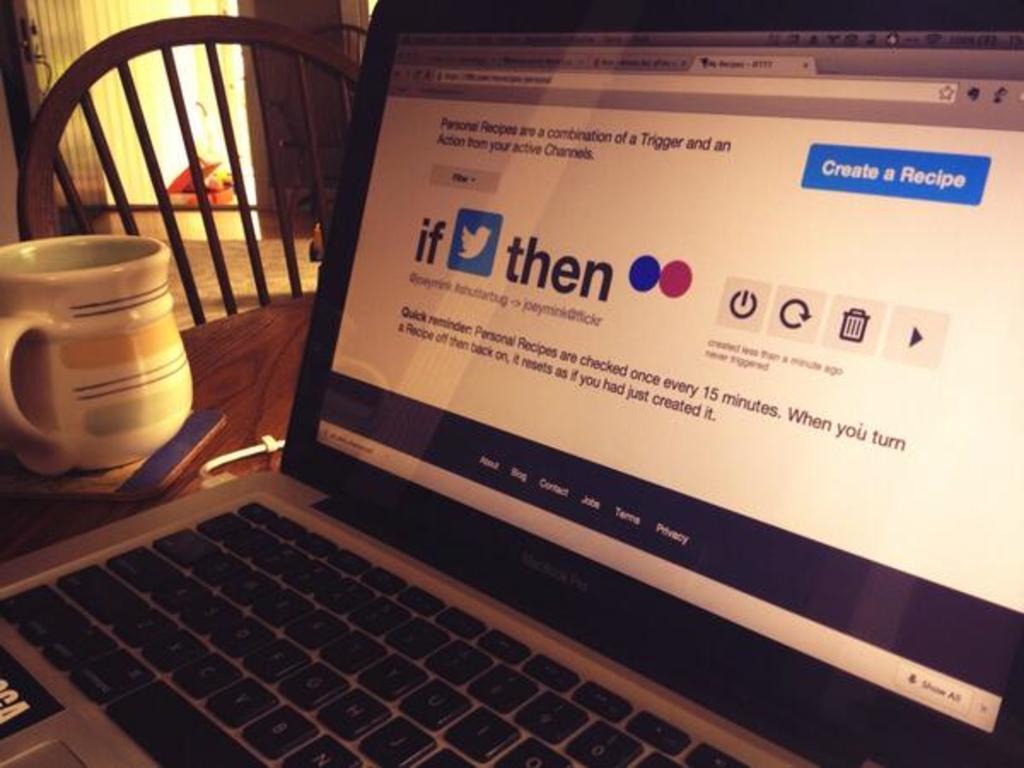Please provide a concise description of this image. In this image i can see a laptop, a cup, a chair on the table. 